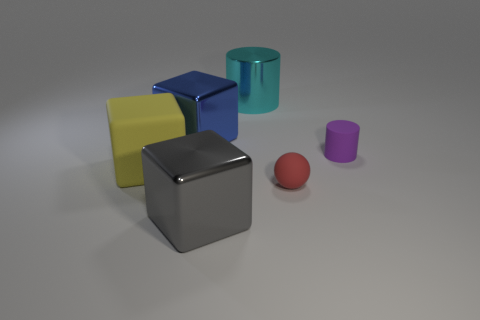What is the material of the gray thing that is the same shape as the yellow matte object?
Offer a very short reply. Metal. Are there any purple rubber cylinders that have the same size as the cyan metal cylinder?
Make the answer very short. No. What size is the yellow thing that is the same material as the red thing?
Provide a short and direct response. Large. There is a red rubber object; what shape is it?
Your response must be concise. Sphere. Does the big gray block have the same material as the cylinder left of the red thing?
Your answer should be very brief. Yes. What number of objects are red rubber spheres or big metal objects?
Your response must be concise. 4. Are any big purple balls visible?
Give a very brief answer. No. What shape is the tiny rubber thing left of the small rubber object that is behind the yellow matte cube?
Ensure brevity in your answer.  Sphere. What number of things are big things to the right of the large blue shiny block or big shiny things that are behind the large blue metallic object?
Provide a short and direct response. 2. There is a blue block that is the same size as the gray metallic block; what is it made of?
Give a very brief answer. Metal. 